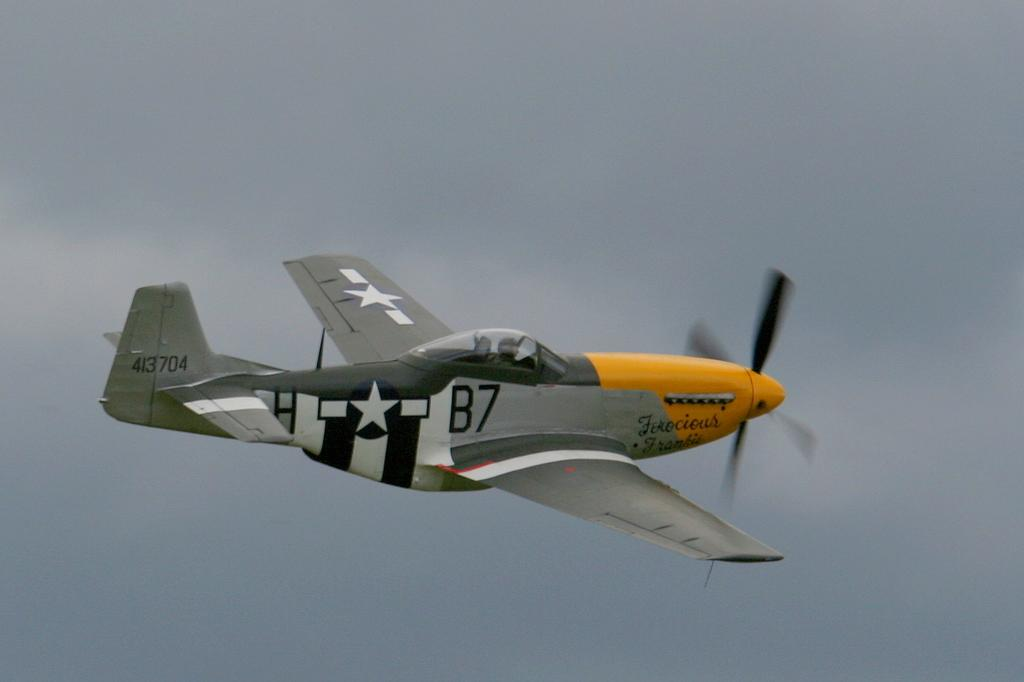Who or what is the main subject in the image? There is a person in the image. What is the person doing in the image? The person is riding a plane. What can be seen in the background of the image? There is sky visible behind the plane. What type of condition does the ray have in the image? There is no ray present in the image; it features a person riding a plane with sky visible in the background. 